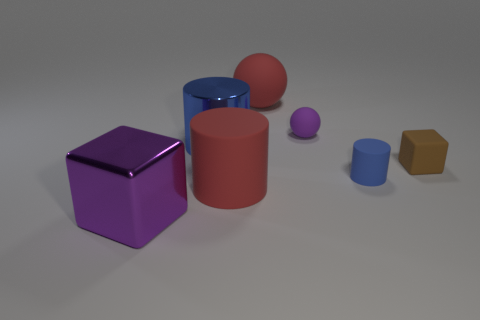There is a large red thing to the right of the red rubber cylinder; what is its shape? The large red object positioned to the right of the red cylinder is a sphere. Its smooth, round surface contrasts with the cylindrical shape of its neighbor. 